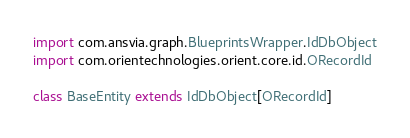Convert code to text. <code><loc_0><loc_0><loc_500><loc_500><_Scala_>import com.ansvia.graph.BlueprintsWrapper.IdDbObject
import com.orientechnologies.orient.core.id.ORecordId

class BaseEntity extends IdDbObject[ORecordId]
</code> 